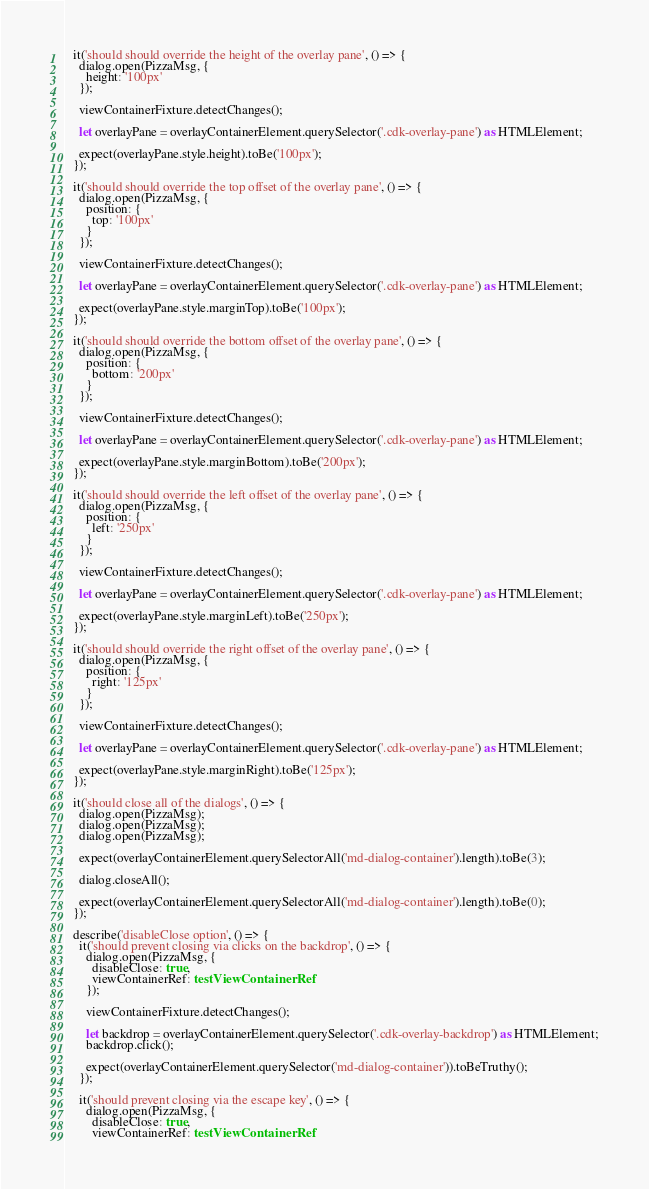Convert code to text. <code><loc_0><loc_0><loc_500><loc_500><_TypeScript_>
  it('should should override the height of the overlay pane', () => {
    dialog.open(PizzaMsg, {
      height: '100px'
    });

    viewContainerFixture.detectChanges();

    let overlayPane = overlayContainerElement.querySelector('.cdk-overlay-pane') as HTMLElement;

    expect(overlayPane.style.height).toBe('100px');
  });

  it('should should override the top offset of the overlay pane', () => {
    dialog.open(PizzaMsg, {
      position: {
        top: '100px'
      }
    });

    viewContainerFixture.detectChanges();

    let overlayPane = overlayContainerElement.querySelector('.cdk-overlay-pane') as HTMLElement;

    expect(overlayPane.style.marginTop).toBe('100px');
  });

  it('should should override the bottom offset of the overlay pane', () => {
    dialog.open(PizzaMsg, {
      position: {
        bottom: '200px'
      }
    });

    viewContainerFixture.detectChanges();

    let overlayPane = overlayContainerElement.querySelector('.cdk-overlay-pane') as HTMLElement;

    expect(overlayPane.style.marginBottom).toBe('200px');
  });

  it('should should override the left offset of the overlay pane', () => {
    dialog.open(PizzaMsg, {
      position: {
        left: '250px'
      }
    });

    viewContainerFixture.detectChanges();

    let overlayPane = overlayContainerElement.querySelector('.cdk-overlay-pane') as HTMLElement;

    expect(overlayPane.style.marginLeft).toBe('250px');
  });

  it('should should override the right offset of the overlay pane', () => {
    dialog.open(PizzaMsg, {
      position: {
        right: '125px'
      }
    });

    viewContainerFixture.detectChanges();

    let overlayPane = overlayContainerElement.querySelector('.cdk-overlay-pane') as HTMLElement;

    expect(overlayPane.style.marginRight).toBe('125px');
  });

  it('should close all of the dialogs', () => {
    dialog.open(PizzaMsg);
    dialog.open(PizzaMsg);
    dialog.open(PizzaMsg);

    expect(overlayContainerElement.querySelectorAll('md-dialog-container').length).toBe(3);

    dialog.closeAll();

    expect(overlayContainerElement.querySelectorAll('md-dialog-container').length).toBe(0);
  });

  describe('disableClose option', () => {
    it('should prevent closing via clicks on the backdrop', () => {
      dialog.open(PizzaMsg, {
        disableClose: true,
        viewContainerRef: testViewContainerRef
      });

      viewContainerFixture.detectChanges();

      let backdrop = overlayContainerElement.querySelector('.cdk-overlay-backdrop') as HTMLElement;
      backdrop.click();

      expect(overlayContainerElement.querySelector('md-dialog-container')).toBeTruthy();
    });

    it('should prevent closing via the escape key', () => {
      dialog.open(PizzaMsg, {
        disableClose: true,
        viewContainerRef: testViewContainerRef</code> 